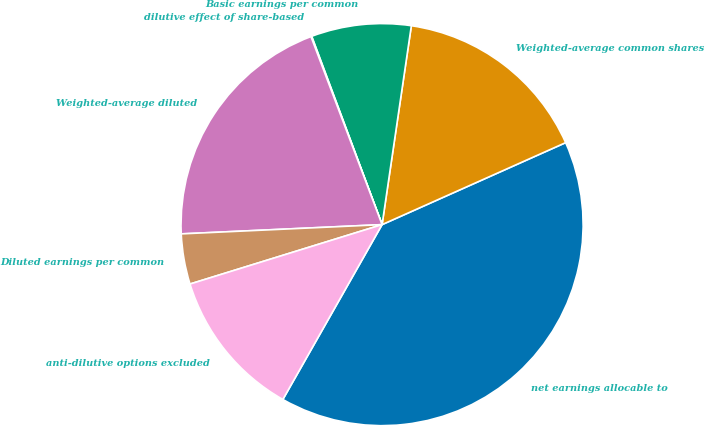Convert chart to OTSL. <chart><loc_0><loc_0><loc_500><loc_500><pie_chart><fcel>net earnings allocable to<fcel>Weighted-average common shares<fcel>Basic earnings per common<fcel>dilutive effect of share-based<fcel>Weighted-average diluted<fcel>Diluted earnings per common<fcel>anti-dilutive options excluded<nl><fcel>39.9%<fcel>15.99%<fcel>8.02%<fcel>0.06%<fcel>19.98%<fcel>4.04%<fcel>12.01%<nl></chart> 